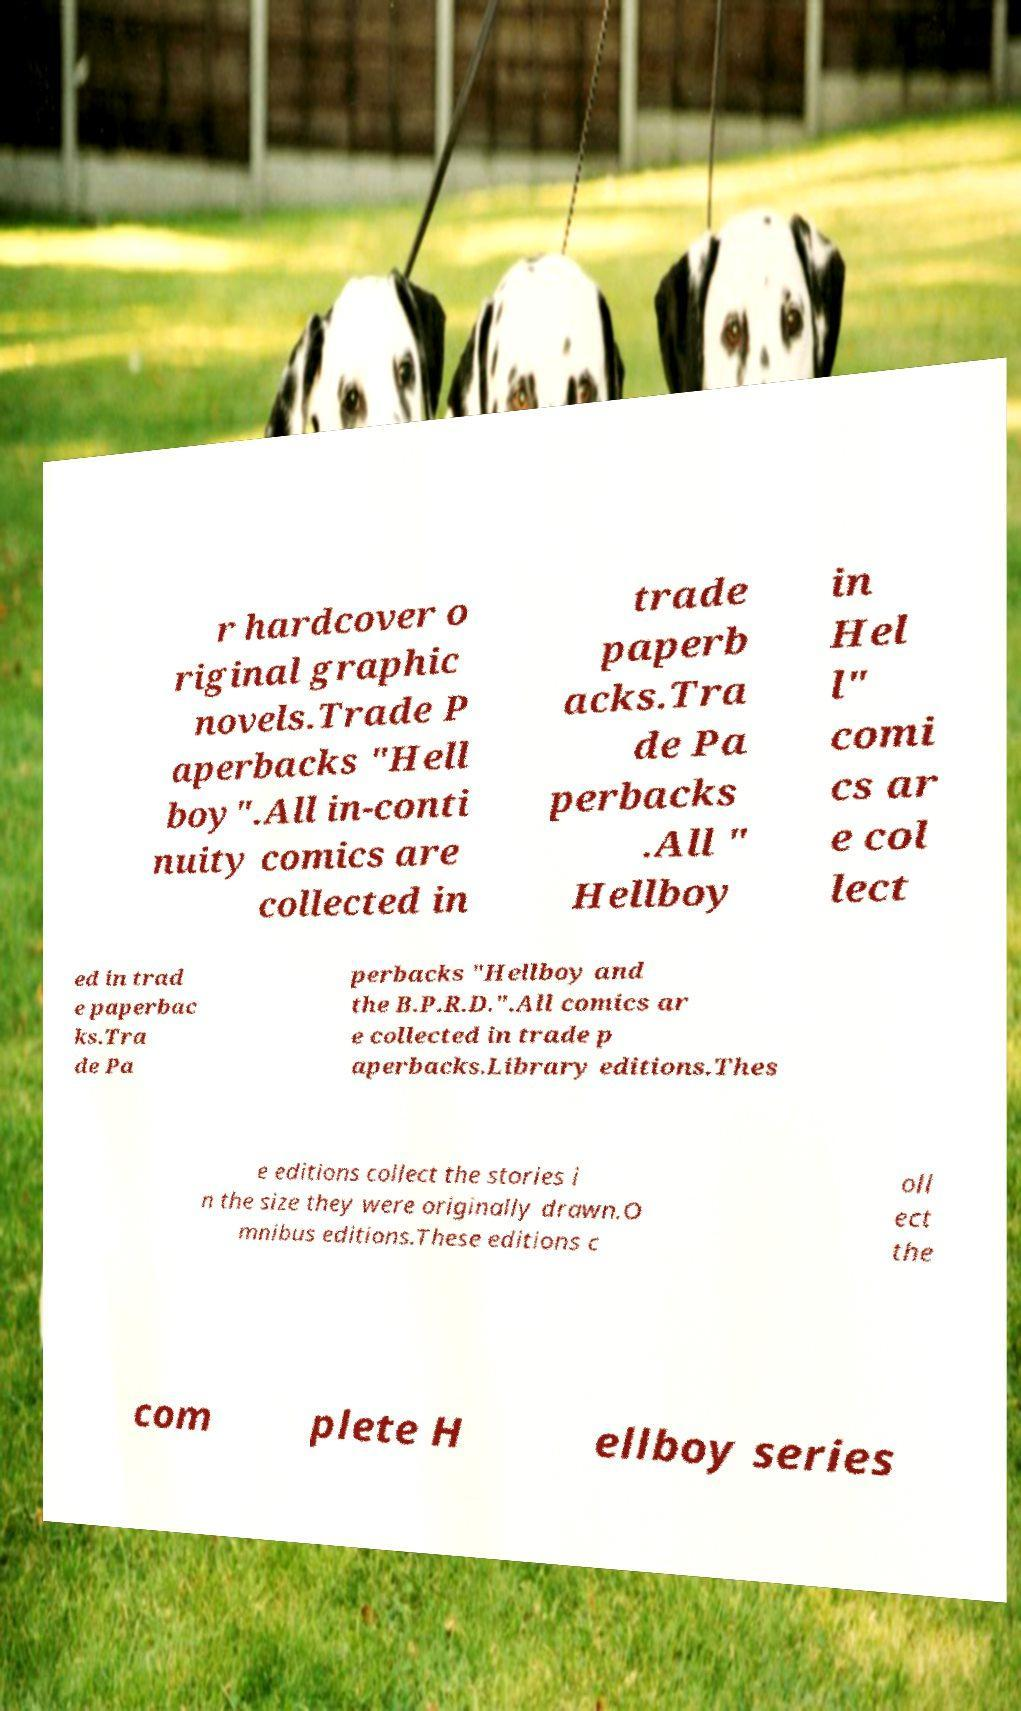Can you read and provide the text displayed in the image?This photo seems to have some interesting text. Can you extract and type it out for me? r hardcover o riginal graphic novels.Trade P aperbacks "Hell boy".All in-conti nuity comics are collected in trade paperb acks.Tra de Pa perbacks .All " Hellboy in Hel l" comi cs ar e col lect ed in trad e paperbac ks.Tra de Pa perbacks "Hellboy and the B.P.R.D.".All comics ar e collected in trade p aperbacks.Library editions.Thes e editions collect the stories i n the size they were originally drawn.O mnibus editions.These editions c oll ect the com plete H ellboy series 